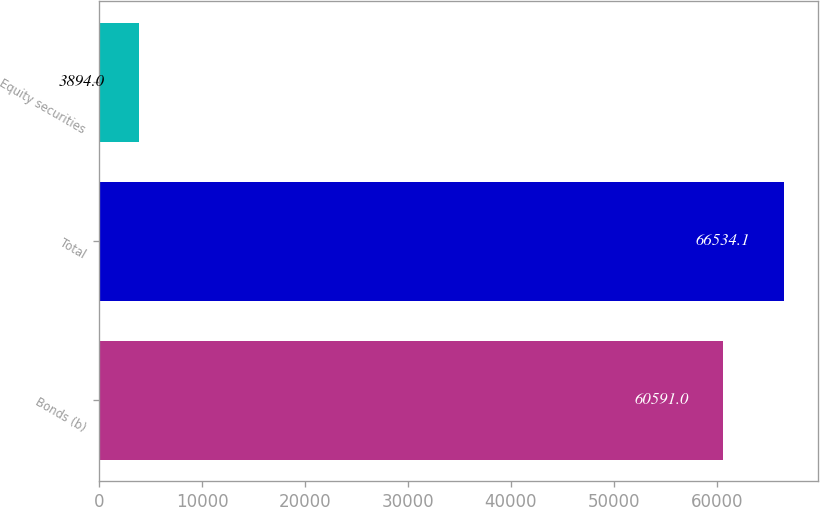Convert chart to OTSL. <chart><loc_0><loc_0><loc_500><loc_500><bar_chart><fcel>Bonds (b)<fcel>Total<fcel>Equity securities<nl><fcel>60591<fcel>66534.1<fcel>3894<nl></chart> 